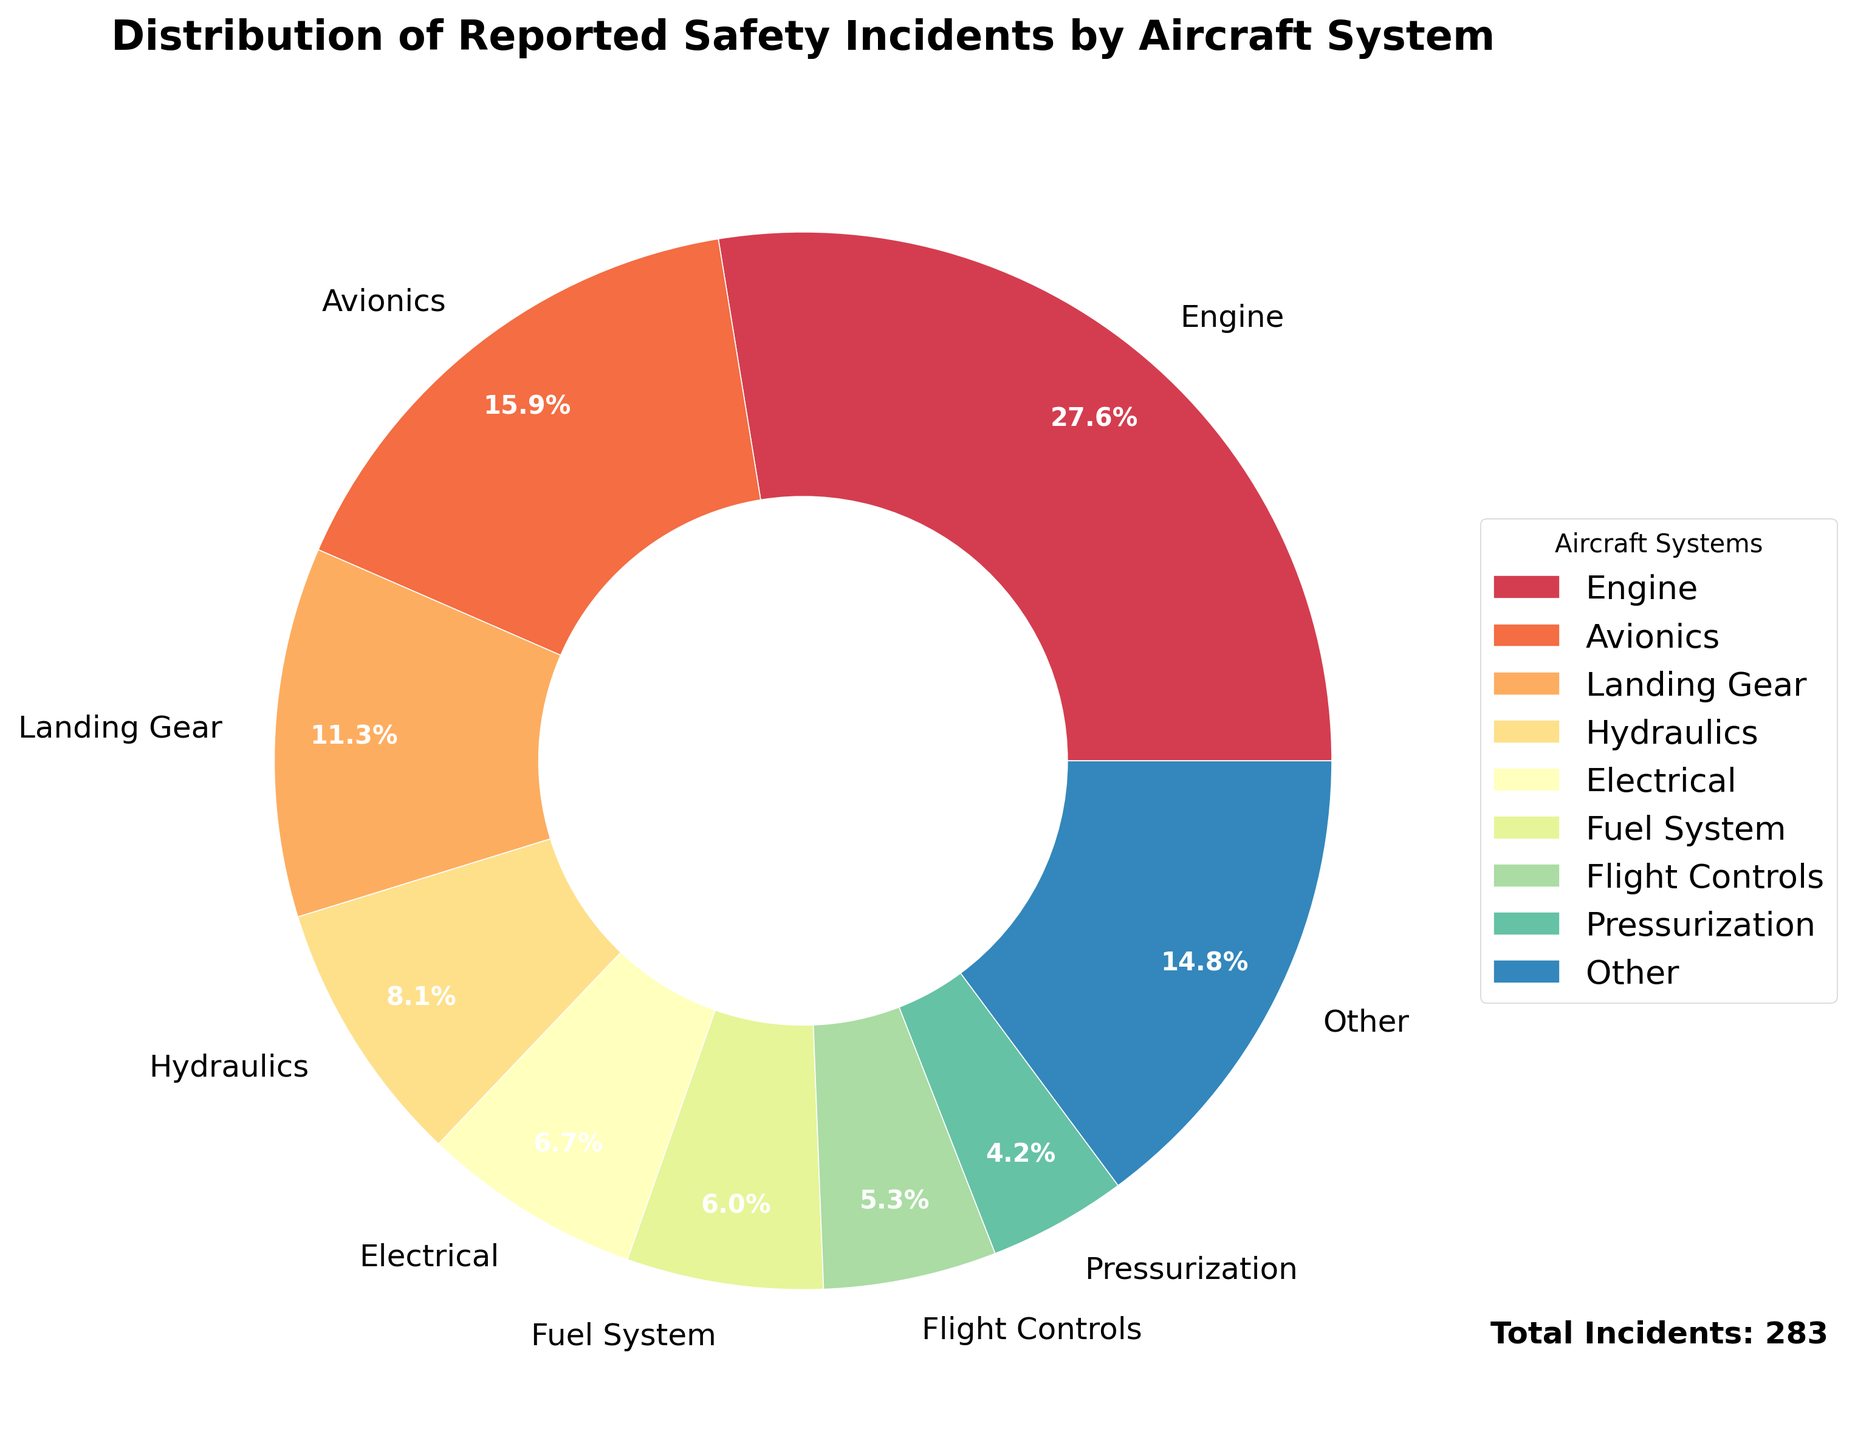What percentage of reported safety incidents are due to issues with the Engine system? To find the percentage of incidents caused by the Engine system, refer to the "Engine" segment in the pie chart and its corresponding label. The label shows the percentage of incidents for each system.
Answer: 33.5% Which system has reported the second-highest percentage of safety incidents? Look at the pie chart and identify the segment with the second-largest proportion after the Engine system. The next largest segment corresponds to the second-highest percentage of incidents.
Answer: Avionics What is the combined percentage of incidents for the top three systems? Identify the top three systems (Engine, Avionics, and Landing Gear) in the pie chart. Sum their percentages: 33.5% (Engine) + 19.3% (Avionics) + 13.7% (Landing Gear).
Answer: 66.5% How does the percentage of incidents related to the Avionics system compare to the Electrical system? Refer to the pie chart and observe the percentages for both Avionics and Electrical systems. Compare the two values to see which is higher.
Answer: Avionics has a higher percentage than Electrical What is the difference in the number of incidents between the Fuel System and Pressurization? Identify the segments for Fuel System and Pressurization in the pie chart. The respective percentages are on the chart, but to find the difference in the number of incidents, multiply each percentage by the total number of incidents (270). Fuel System: 17/270, Pressurization: 12/270. Thus, the difference is 5.
Answer: 5 Which system has the smallest visual segment in the pie chart? Identify the smallest segment in the pie chart, which corresponds to the system with the fewest incidents.
Answer: Auxiliary Power Unit In terms of percentage, how much more prevalent are incidents in the Landing Gear system compared to the Hydraulics system? Find the percentages for both Landing Gear (13.7%) and Hydraulics (8.5%) in the pie chart. Calculate the difference: 13.7% - 8.5%.
Answer: 5.2% Are the reported incidents in the Air Conditioning system greater than those in the Navigation system? Compare the respective segments for Air Conditioning and Navigation in the pie chart and refer to their percentage values. Check which value is higher.
Answer: Yes What's the combined percentage for systems grouped under "Other"? Identify the percentage for the "Other" category directly from the pie chart. This category includes the systems not in the top 8, combining their total percentages.
Answer: 9.6% What is the total number of incidents reported for the top eight systems combined? Calculate the total number of incidents by summing the incidents for each of the top eight systems. This can be verified by checking if it's the same as the sum of the percentages (excluding "Other") multiplied by the total number of incidents. The top 8 systems have 251 incidents out of 270 based on the data.
Answer: 251 